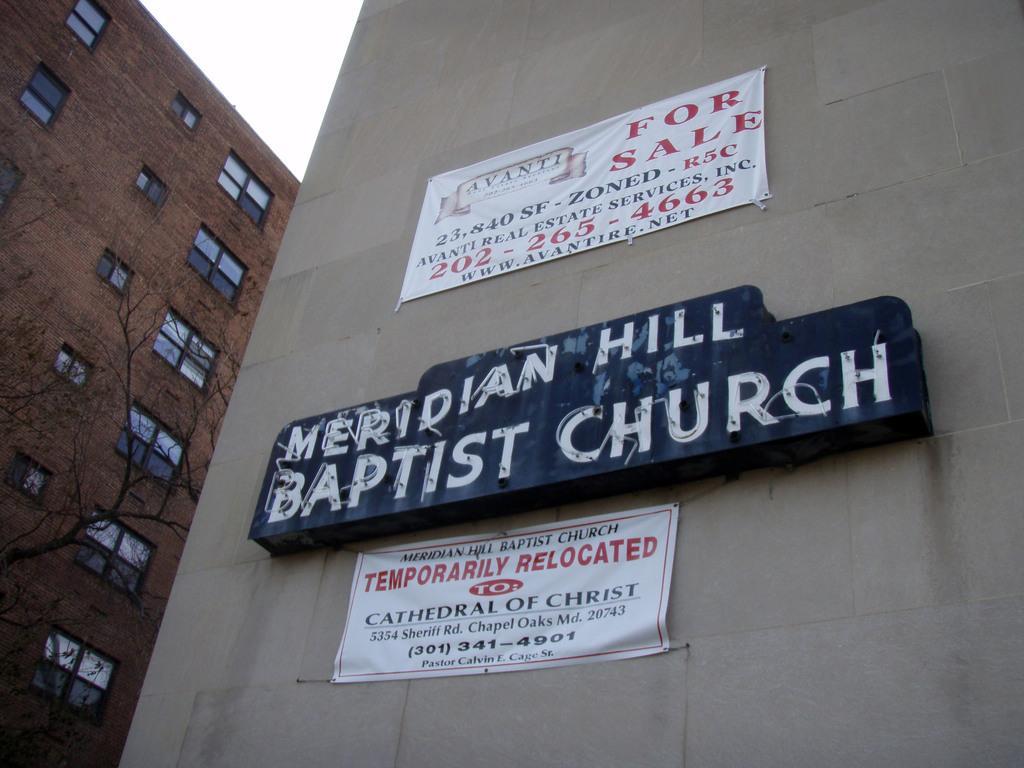Can you describe this image briefly? In this image there are trees and buildings, on the buildings there are name boards and banners. 